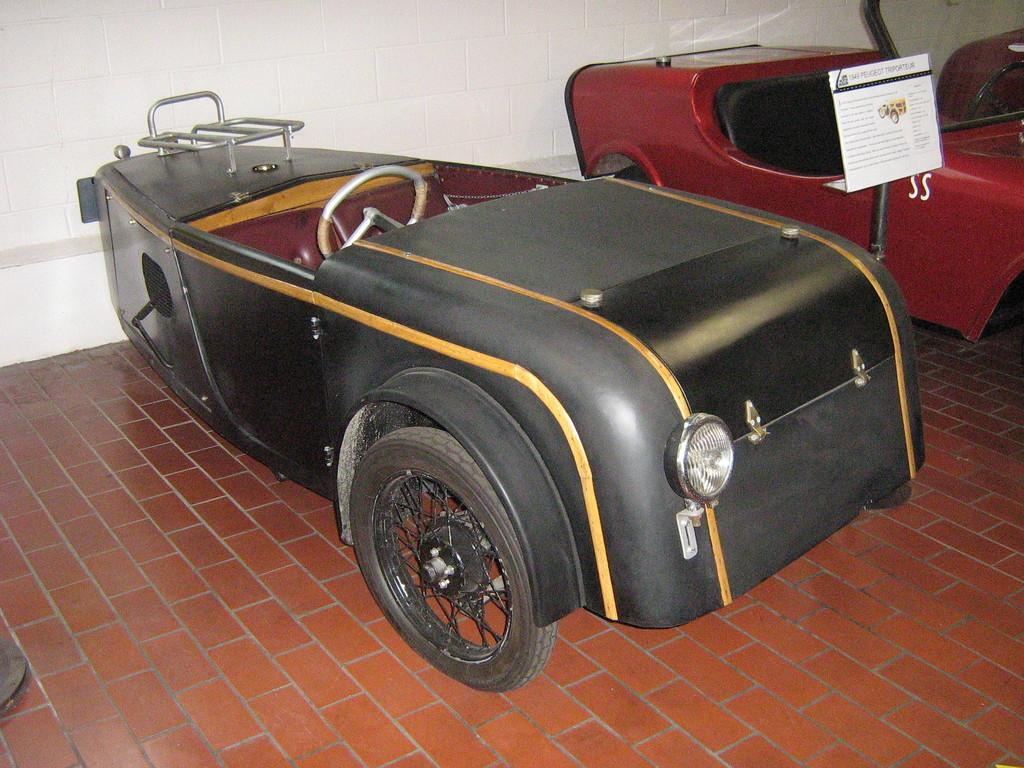How many vehicles are present in the image? There are two vehicles in the image. Where are the vehicles located? The vehicles are on the floor. What is present between the two vehicles? There is a pole with a board in between the vehicles. What can be seen behind the vehicles? There is a wall behind the vehicles. What type of food is being prepared on the vehicles' roofs in the image? There is no food or preparation of food visible in the image; the focus is on the vehicles, pole, board, and wall. 